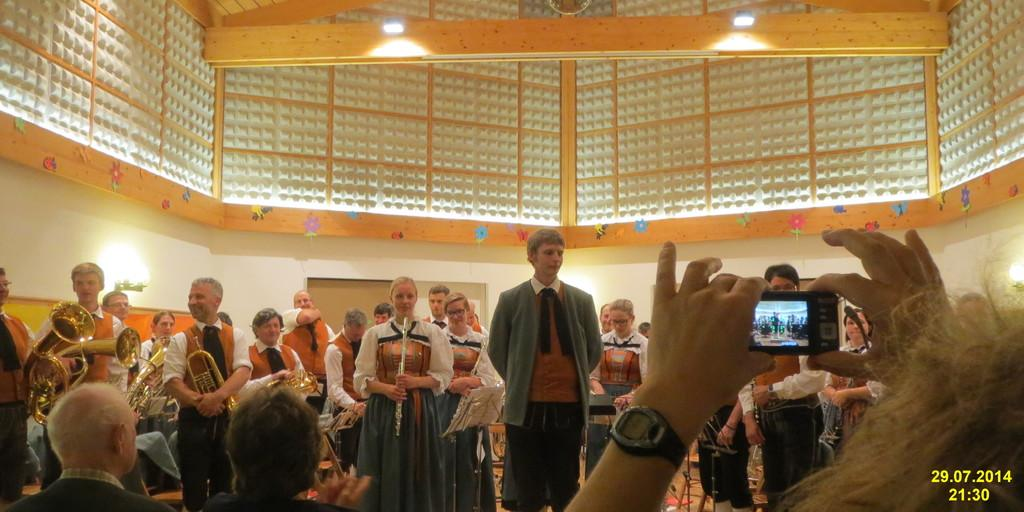<image>
Create a compact narrative representing the image presented. The video shown of this crowd was recorded at 21.30. 